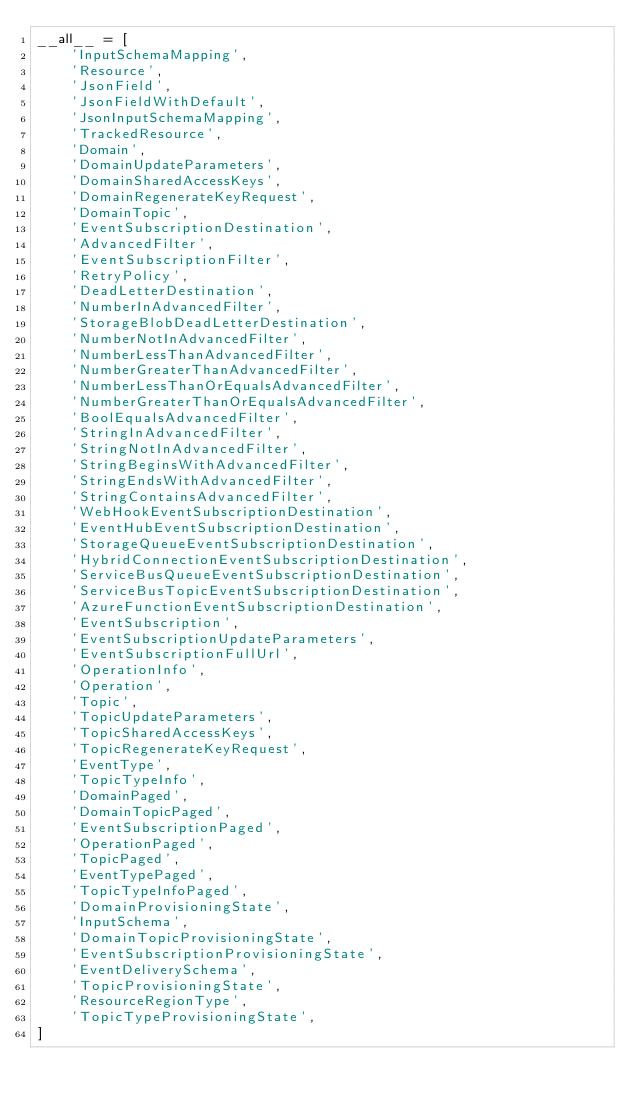<code> <loc_0><loc_0><loc_500><loc_500><_Python_>__all__ = [
    'InputSchemaMapping',
    'Resource',
    'JsonField',
    'JsonFieldWithDefault',
    'JsonInputSchemaMapping',
    'TrackedResource',
    'Domain',
    'DomainUpdateParameters',
    'DomainSharedAccessKeys',
    'DomainRegenerateKeyRequest',
    'DomainTopic',
    'EventSubscriptionDestination',
    'AdvancedFilter',
    'EventSubscriptionFilter',
    'RetryPolicy',
    'DeadLetterDestination',
    'NumberInAdvancedFilter',
    'StorageBlobDeadLetterDestination',
    'NumberNotInAdvancedFilter',
    'NumberLessThanAdvancedFilter',
    'NumberGreaterThanAdvancedFilter',
    'NumberLessThanOrEqualsAdvancedFilter',
    'NumberGreaterThanOrEqualsAdvancedFilter',
    'BoolEqualsAdvancedFilter',
    'StringInAdvancedFilter',
    'StringNotInAdvancedFilter',
    'StringBeginsWithAdvancedFilter',
    'StringEndsWithAdvancedFilter',
    'StringContainsAdvancedFilter',
    'WebHookEventSubscriptionDestination',
    'EventHubEventSubscriptionDestination',
    'StorageQueueEventSubscriptionDestination',
    'HybridConnectionEventSubscriptionDestination',
    'ServiceBusQueueEventSubscriptionDestination',
    'ServiceBusTopicEventSubscriptionDestination',
    'AzureFunctionEventSubscriptionDestination',
    'EventSubscription',
    'EventSubscriptionUpdateParameters',
    'EventSubscriptionFullUrl',
    'OperationInfo',
    'Operation',
    'Topic',
    'TopicUpdateParameters',
    'TopicSharedAccessKeys',
    'TopicRegenerateKeyRequest',
    'EventType',
    'TopicTypeInfo',
    'DomainPaged',
    'DomainTopicPaged',
    'EventSubscriptionPaged',
    'OperationPaged',
    'TopicPaged',
    'EventTypePaged',
    'TopicTypeInfoPaged',
    'DomainProvisioningState',
    'InputSchema',
    'DomainTopicProvisioningState',
    'EventSubscriptionProvisioningState',
    'EventDeliverySchema',
    'TopicProvisioningState',
    'ResourceRegionType',
    'TopicTypeProvisioningState',
]
</code> 